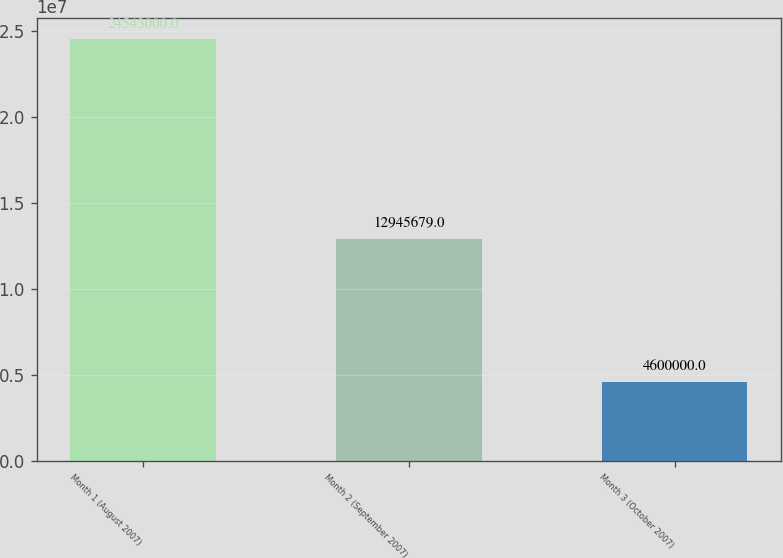<chart> <loc_0><loc_0><loc_500><loc_500><bar_chart><fcel>Month 1 (August 2007)<fcel>Month 2 (September 2007)<fcel>Month 3 (October 2007)<nl><fcel>2.4543e+07<fcel>1.29457e+07<fcel>4.6e+06<nl></chart> 